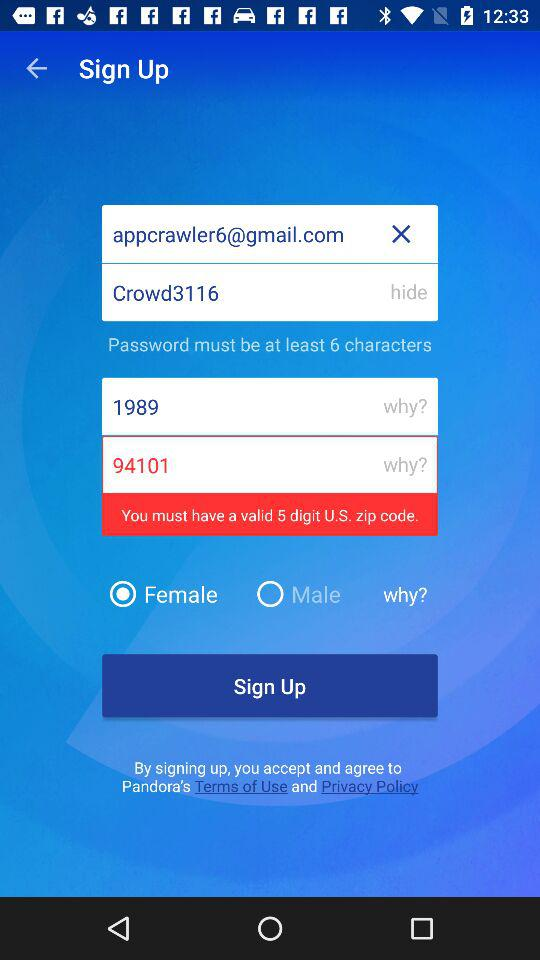What is the email address? The email address is appcrawler6@gmail.com. 